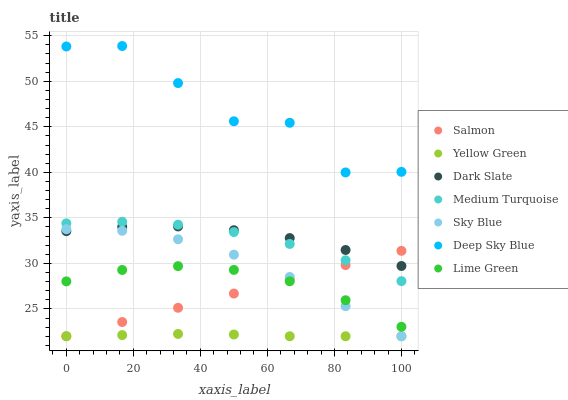Does Yellow Green have the minimum area under the curve?
Answer yes or no. Yes. Does Deep Sky Blue have the maximum area under the curve?
Answer yes or no. Yes. Does Salmon have the minimum area under the curve?
Answer yes or no. No. Does Salmon have the maximum area under the curve?
Answer yes or no. No. Is Salmon the smoothest?
Answer yes or no. Yes. Is Deep Sky Blue the roughest?
Answer yes or no. Yes. Is Yellow Green the smoothest?
Answer yes or no. No. Is Yellow Green the roughest?
Answer yes or no. No. Does Yellow Green have the lowest value?
Answer yes or no. Yes. Does Dark Slate have the lowest value?
Answer yes or no. No. Does Deep Sky Blue have the highest value?
Answer yes or no. Yes. Does Salmon have the highest value?
Answer yes or no. No. Is Lime Green less than Deep Sky Blue?
Answer yes or no. Yes. Is Deep Sky Blue greater than Lime Green?
Answer yes or no. Yes. Does Medium Turquoise intersect Dark Slate?
Answer yes or no. Yes. Is Medium Turquoise less than Dark Slate?
Answer yes or no. No. Is Medium Turquoise greater than Dark Slate?
Answer yes or no. No. Does Lime Green intersect Deep Sky Blue?
Answer yes or no. No. 